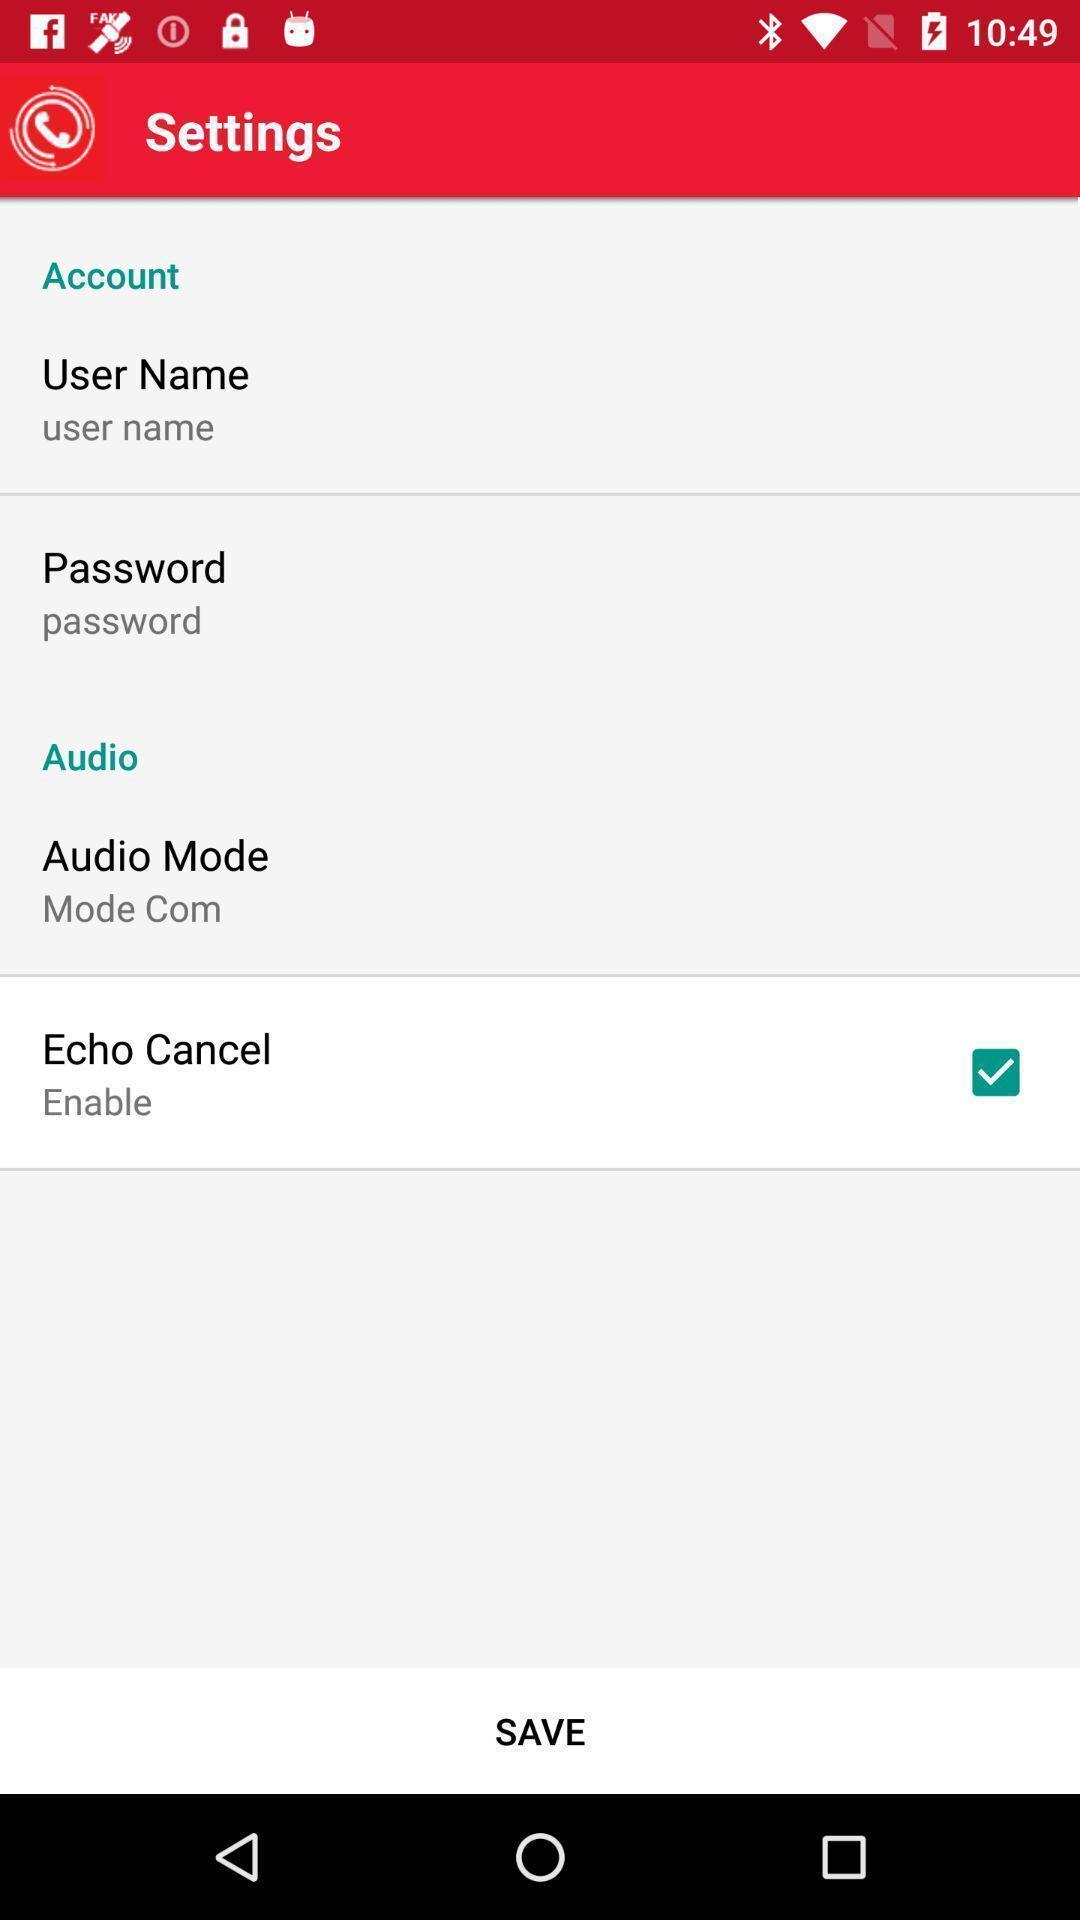Tell me what you see in this picture. Settings page of a technical app. 